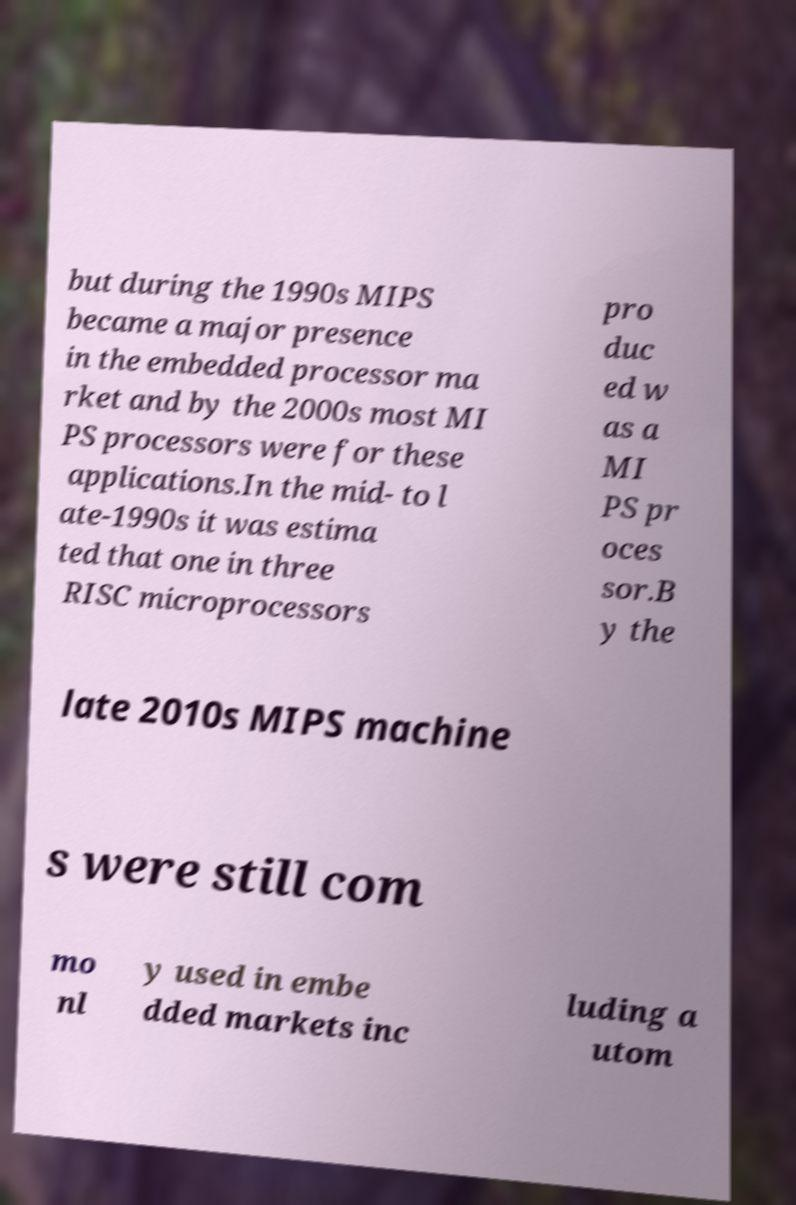There's text embedded in this image that I need extracted. Can you transcribe it verbatim? but during the 1990s MIPS became a major presence in the embedded processor ma rket and by the 2000s most MI PS processors were for these applications.In the mid- to l ate-1990s it was estima ted that one in three RISC microprocessors pro duc ed w as a MI PS pr oces sor.B y the late 2010s MIPS machine s were still com mo nl y used in embe dded markets inc luding a utom 